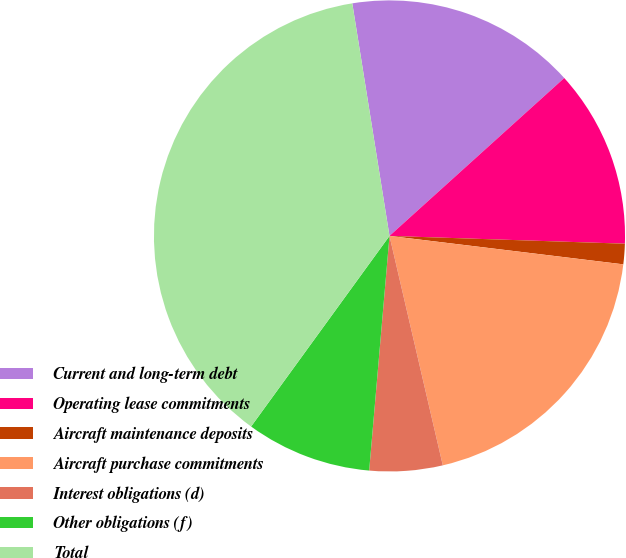<chart> <loc_0><loc_0><loc_500><loc_500><pie_chart><fcel>Current and long-term debt<fcel>Operating lease commitments<fcel>Aircraft maintenance deposits<fcel>Aircraft purchase commitments<fcel>Interest obligations (d)<fcel>Other obligations (f)<fcel>Total<nl><fcel>15.83%<fcel>12.22%<fcel>1.4%<fcel>19.44%<fcel>5.01%<fcel>8.62%<fcel>37.48%<nl></chart> 